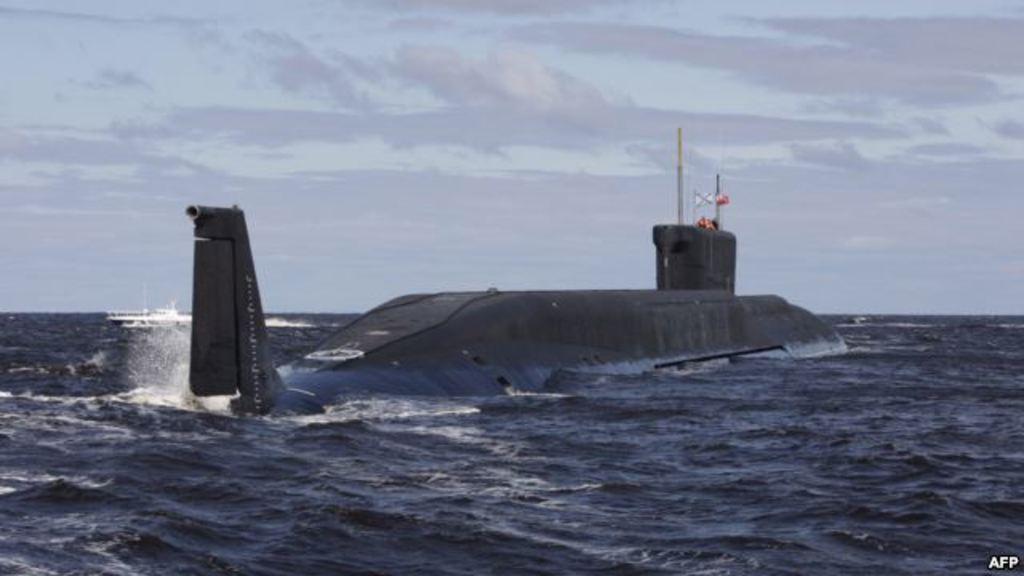How would you summarize this image in a sentence or two? At the bottom of the image we can see water, above the water we can see a submarine and ship. At the top of the image we can see some clouds in the sky. 